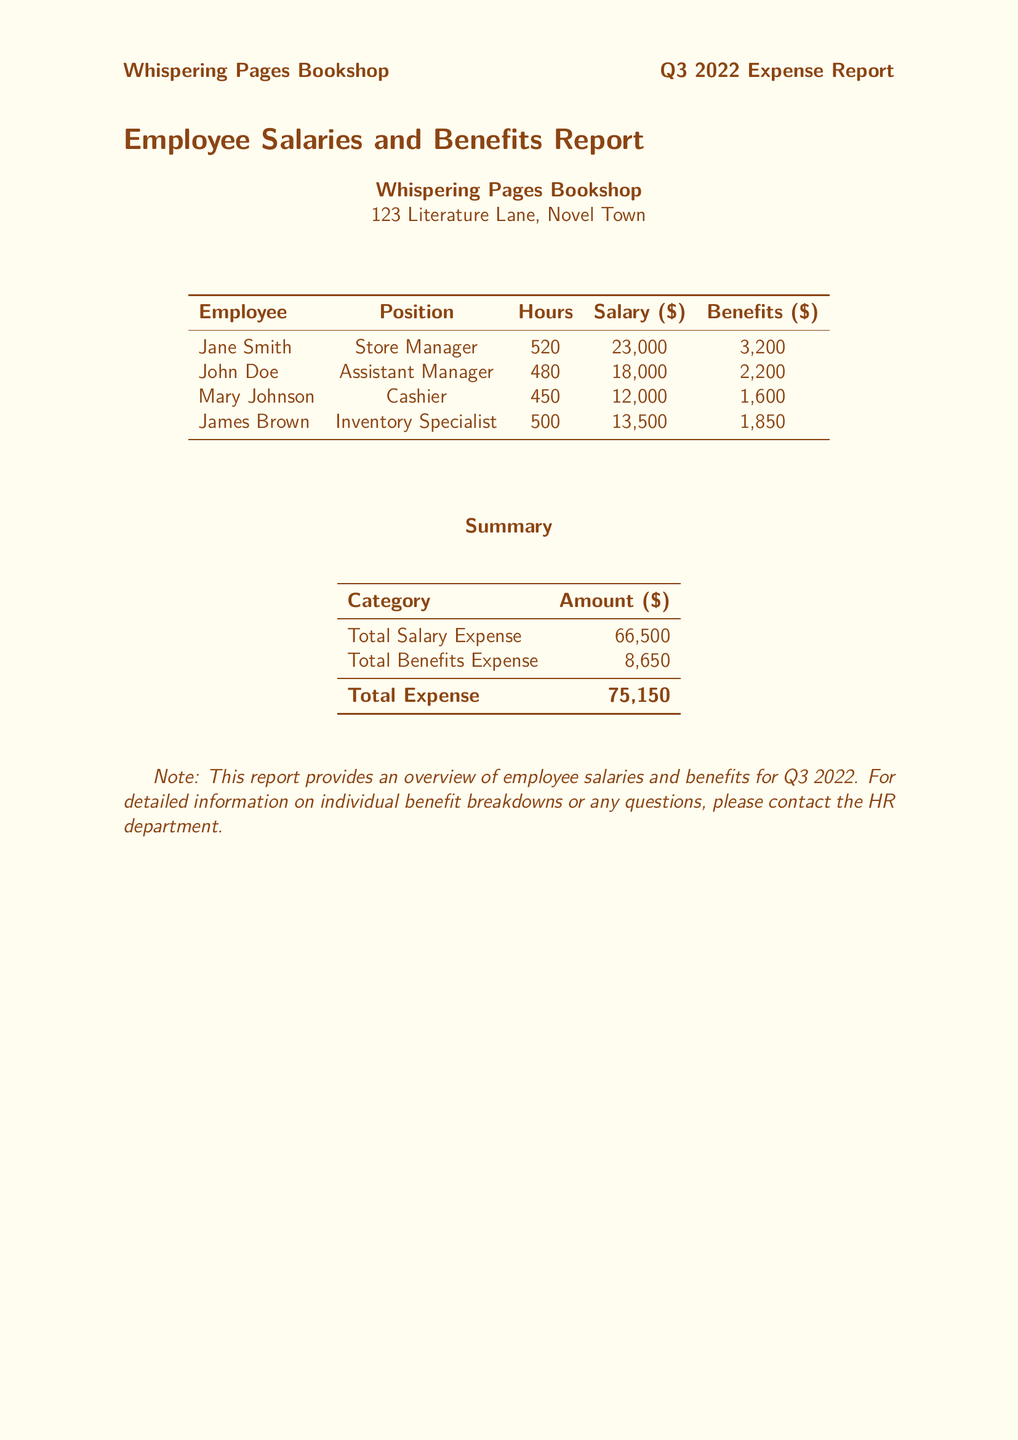What is the total salary expense? The total salary expense is provided at the bottom of the summary table in the document.
Answer: 66,500 Who is the Store Manager? The first row of the employee table names Jane Smith as the Store Manager.
Answer: Jane Smith How many hours did the Cashier work? The number of hours worked by each employee is shown in the third column of the employee table.
Answer: 450 What is the total benefits expense? The total benefits expense is listed in the summary table under “Total Benefits Expense.”
Answer: 8,650 How much does John Doe earn in salary? The salary for John Doe is shown in the fourth column of the employee table.
Answer: 18,000 Which position has the highest benefits? By comparing the benefits of each employee, we can determine which position received the highest amount.
Answer: Store Manager How many hours did the Inventory Specialist work? The hours worked by the Inventory Specialist can be found in the employee table next to James Brown’s name.
Answer: 500 What is the total expense calculated in the document? The total expense is recorded in the summary table as the sum of total salary and benefits expenses.
Answer: 75,150 How much are the total benefits for all employees combined? The total benefits is a single value shown in the summary table, detailing combined benefits.
Answer: 8,650 